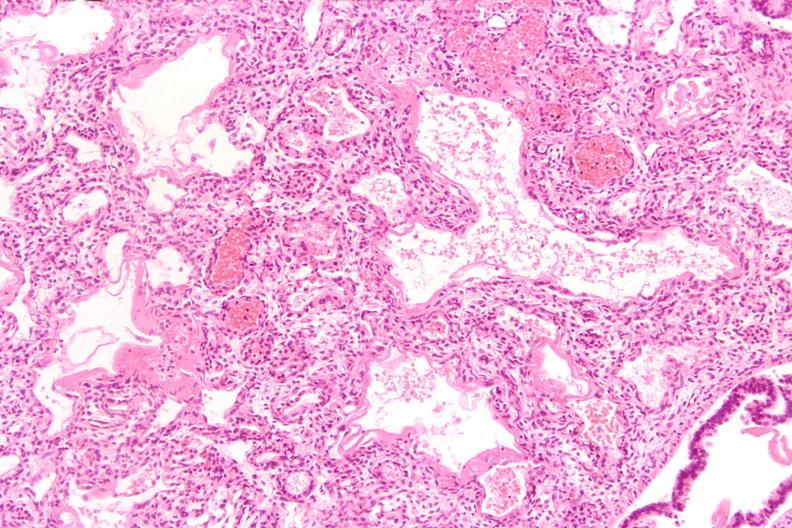s respiratory present?
Answer the question using a single word or phrase. Yes 